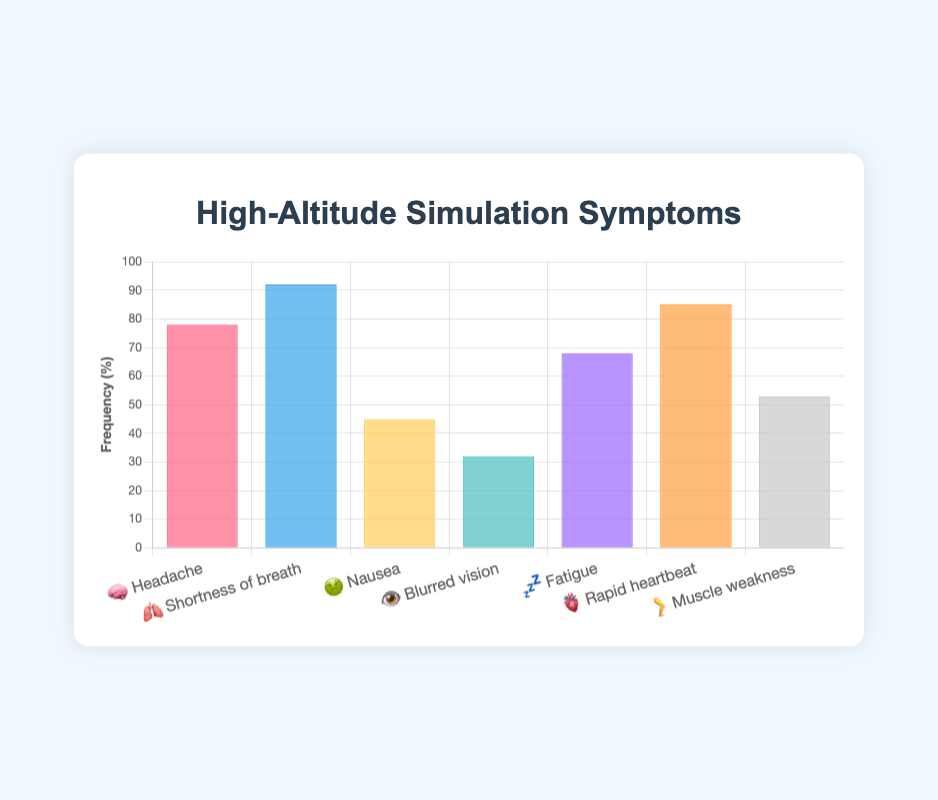What is the title of the chart? The title is displayed at the top of the chart. It reads "High-Altitude Simulation Symptoms".
Answer: High-Altitude Simulation Symptoms Which symptom has the highest frequency? Look at the tallest bar in the chart; it corresponds to "🫁 Shortness of breath" with a frequency of 92%.
Answer: Shortness of breath What is the frequency of the "🧠 Headache" symptom? Find the bar labeled "🧠 Headache" and check its height, which represents the frequency; it is 78%.
Answer: 78% How many symptoms have a frequency greater than 50%? Count the number of bars that extend above the 50% mark. They are "🧠 Headache", "🫁 Shortness of breath", "💤 Fatigue", "🫀 Rapid heartbeat", and "🦵 Muscle weakness". There are 5 such symptoms.
Answer: 5 Which symptom has the lowest frequency? Look for the shortest bar in the chart; it corresponds to "👁️ Blurred vision" with a frequency of 32%.
Answer: Blurred vision What is the difference in frequency between "🦵 Muscle weakness" and "💤 Fatigue"? Note the frequencies of "🦵 Muscle weakness" (53%) and "💤 Fatigue" (68%). The difference is 68% - 53% = 15%.
Answer: 15% Is there any symptom with exactly 50% frequency? Check each bar's height to see if any line up directly with the 50% mark; none do.
Answer: No Which symptom group experiences a frequency closer to 80%, "🧠 Headache" or "🫀 Rapid heartbeat"? Compare the frequencies of "🧠 Headache" (78%) and "🫀 Rapid heartbeat" (85%) with 80%. "🧠 Headache" is closer to 80%.
Answer: Headache What is the average frequency of all the symptoms displayed in the chart? Sum up all the frequencies and divide by the number of symptoms. (78 + 92 + 45 + 32 + 68 + 85 + 53) / 7 = 453 / 7 = 64.71%.
Answer: 64.71% How many colors are used to represent the symptoms? Count the different colors in the chart, each unique to a symptom. There are 7 colors.
Answer: 7 